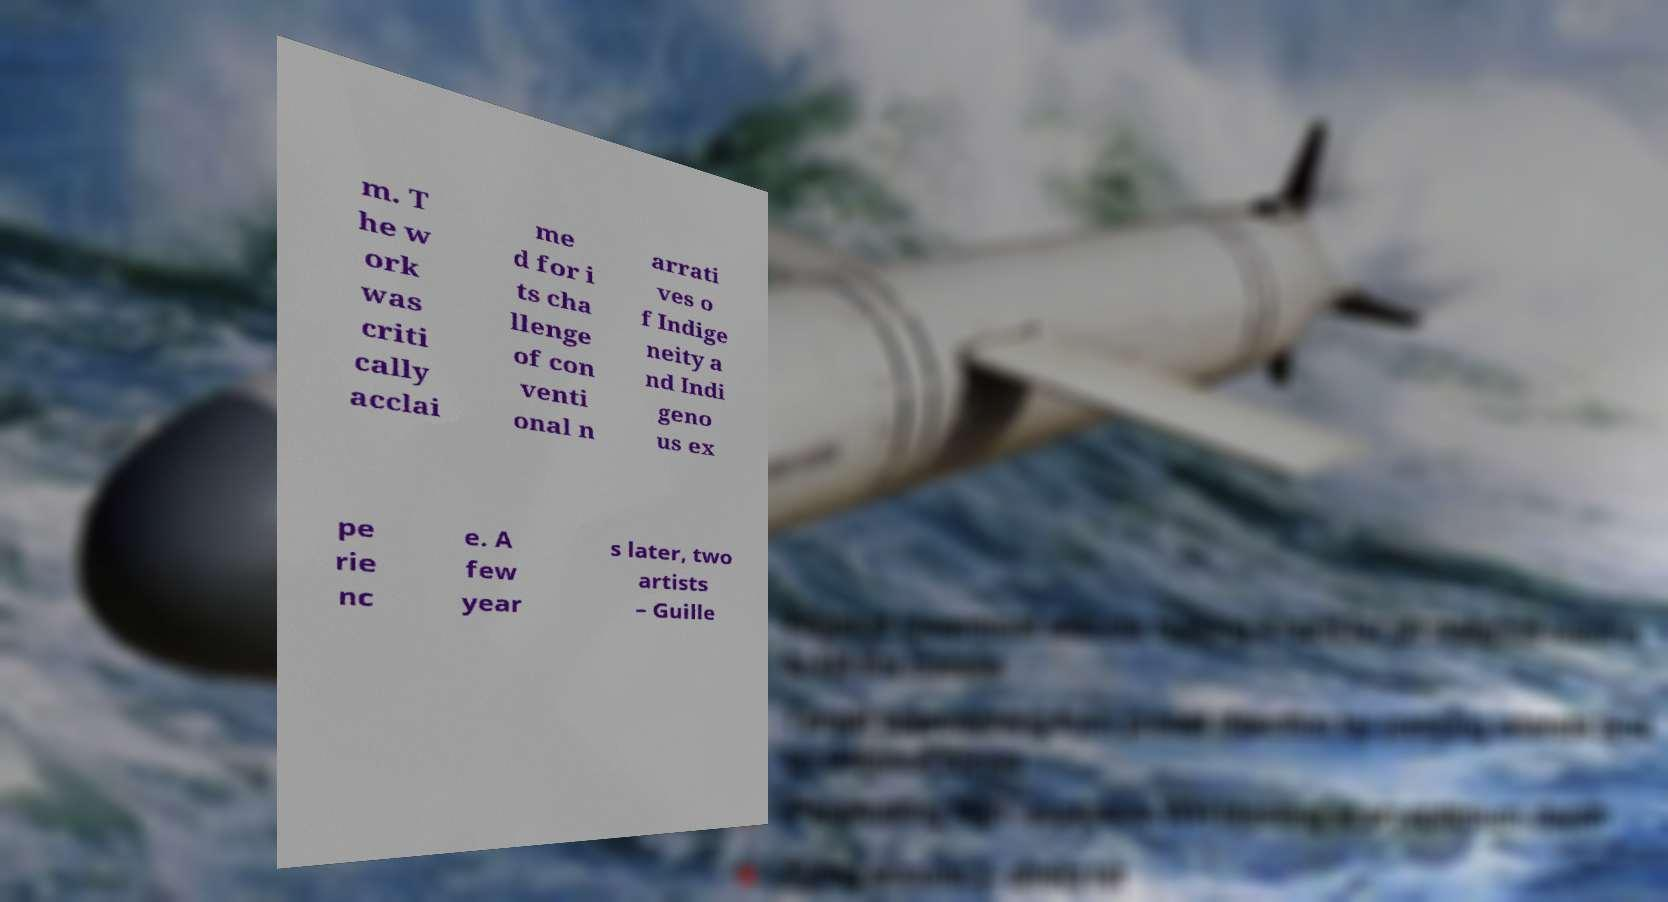For documentation purposes, I need the text within this image transcribed. Could you provide that? m. T he w ork was criti cally acclai me d for i ts cha llenge of con venti onal n arrati ves o f Indige neity a nd Indi geno us ex pe rie nc e. A few year s later, two artists – Guille 